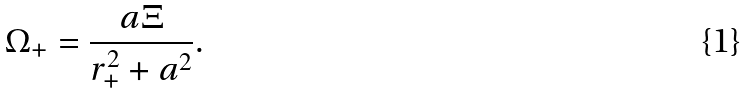Convert formula to latex. <formula><loc_0><loc_0><loc_500><loc_500>\Omega _ { + } = \frac { a \Xi } { r _ { + } ^ { 2 } + a ^ { 2 } } .</formula> 